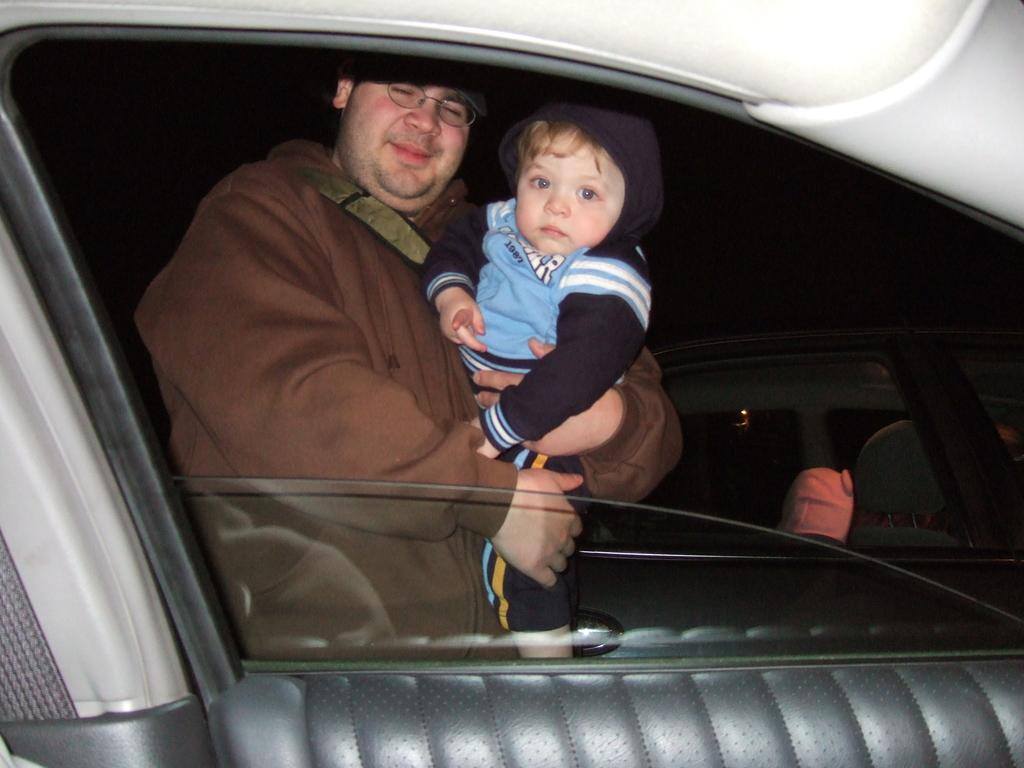Who is present in the image? There is a man in the image. What is the man doing in the image? The man is carrying a baby in his hands. What is the setting of the image? The image shows the inside view of a car. Are there any other vehicles visible in the image? Yes, there is another car visible in the image. What type of soap is the man using to clean the vase in the image? There is no soap or vase present in the image; it features a man carrying a baby in a car. 